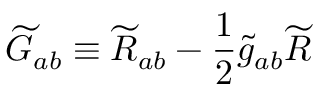Convert formula to latex. <formula><loc_0><loc_0><loc_500><loc_500>{ \widetilde { G } } _ { a b } \equiv \widetilde { R } _ { a b } - { \frac { 1 } { 2 } } { \widetilde { g } } _ { a b } { \widetilde { R } }</formula> 